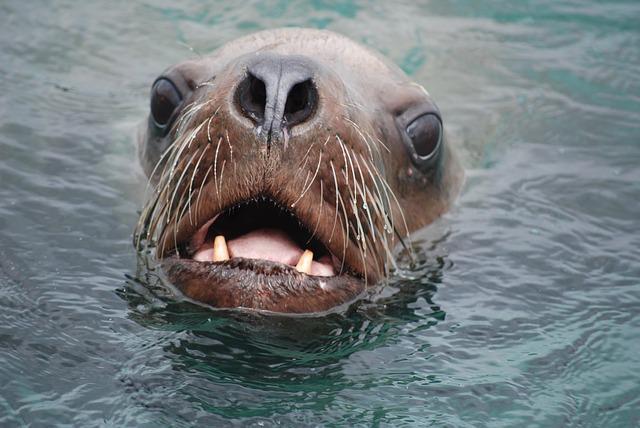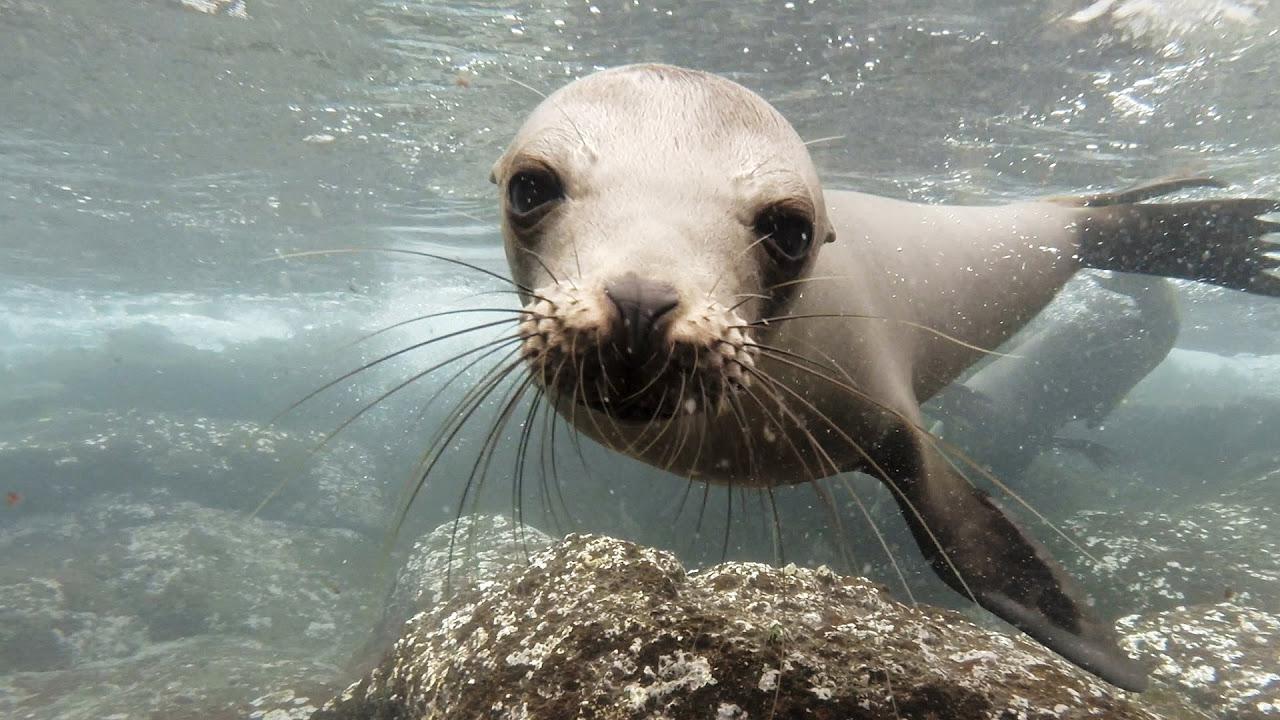The first image is the image on the left, the second image is the image on the right. Analyze the images presented: Is the assertion "The mouth of the seal in one of the images is open." valid? Answer yes or no. Yes. The first image is the image on the left, the second image is the image on the right. For the images shown, is this caption "A seal's body is submerged in water up to its neck in one of the images." true? Answer yes or no. Yes. 